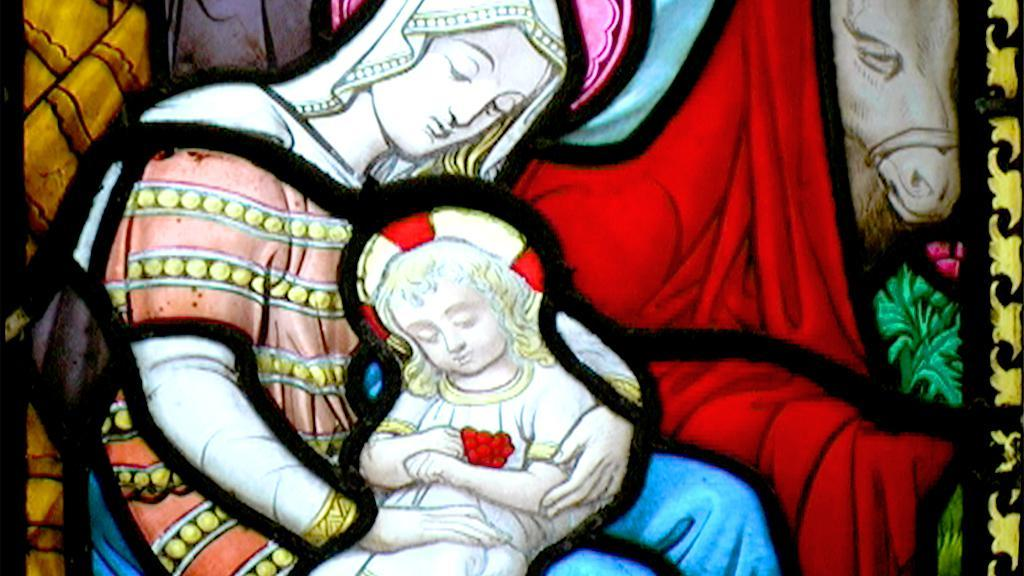What is depicted in the painting in the image? There is a painting of a person sitting with a kid in their lap. Are there any other subjects in the painting? Yes, there is a painting of a horse standing. What type of stone is the box made of in the image? There is no box present in the image, so it is not possible to determine what type of stone it might be made of. 